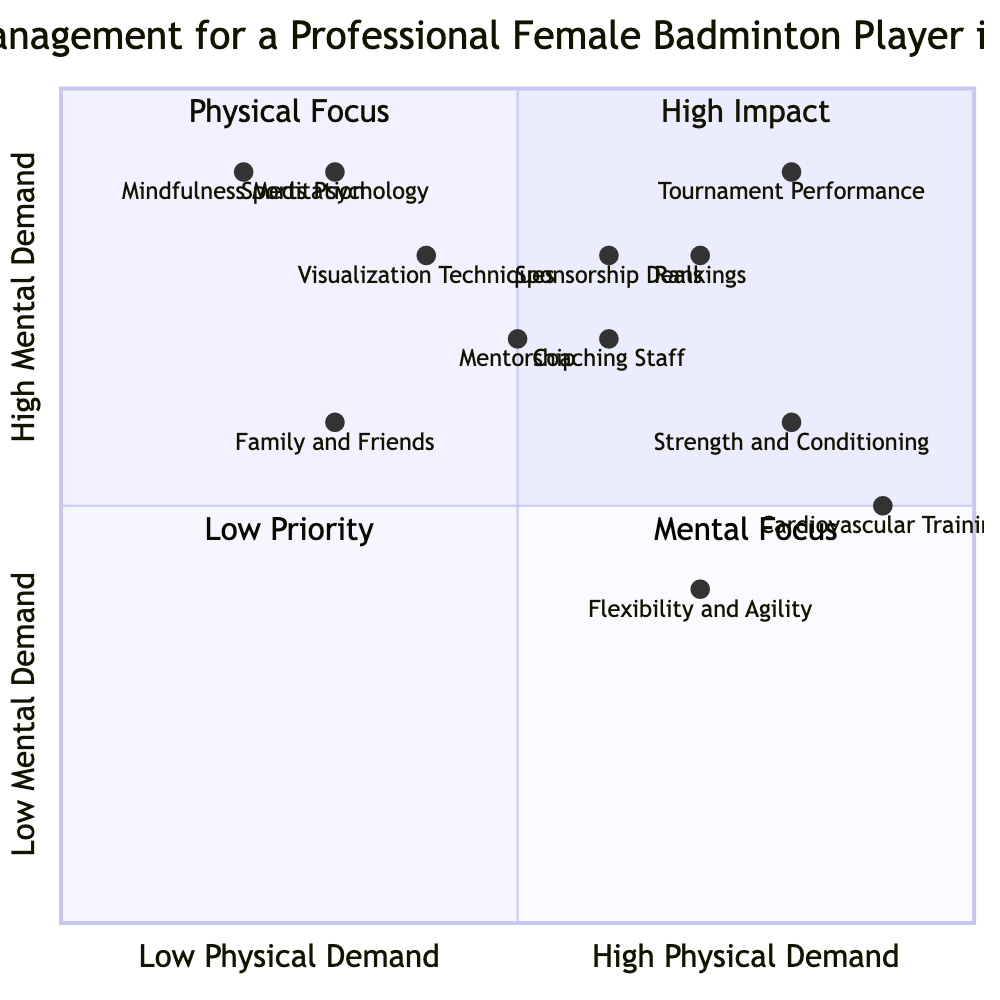What is the element with the highest physical demand? By reviewing the x-axis values for all elements, Cardiovascular Training has the highest physical demand at 0.9, meaning it is positioned furthest right on the diagram.
Answer: Cardiovascular Training Which element has the greatest mental focus? Looking at the y-axis values, Mindfulness Meditation has the highest mental demand at 0.9, indicating it is placed at the top of the diagram, within the Mental Focus quadrant.
Answer: Mindfulness Meditation How many elements fall into the High Impact quadrant? Checking the quadrant locations, there are four elements: Mindfulness Meditation, Sports Psychology, Tournament Performance, and Visualization Techniques.
Answer: 4 What do Sponsorship Deals and Rankings have in common? Both elements fall within the High Impact quadrant and have similar y-axis values (0.8), indicating both involve high mental demand and high performance pressure while also requiring significant physical fitness.
Answer: High Impact quadrant Which element represents the lowest mental demand? By examining the y-axis values, Flexibility and Agility has the lowest mental demand at 0.4, placing it at the bottom of the quadrant in terms of mental focus.
Answer: Flexibility and Agility Which quadrant contains elements with both high physical and mental demands? In the diagram, the High Impact quadrant includes elements that exhibit both high physical demand and high mental demand, making this the quadrant of focus for overall stress management.
Answer: High Impact What is the average mental demand for elements in the Support System category? The y-axis values for Coaching Staff (0.7), Family and Friends (0.6), and Mentorship (0.7) average to 0.67. Adding those values (0.7 + 0.6 + 0.7 = 2.0) and dividing by three gives 0.67.
Answer: 0.67 What is the lowest physical demand element? By observing the x-axis values, Mindfulness Meditation has the lowest physical demand at 0.2, which places it the furthest left on the diagram.
Answer: Mindfulness Meditation Which two elements are closest on the x-axis? Comparing the x-axis values for Flexibility and Agility (0.7) and Coaching Staff (0.6), these are the two closest elements horizontally on the diagram.
Answer: Flexibility and Agility and Coaching Staff 